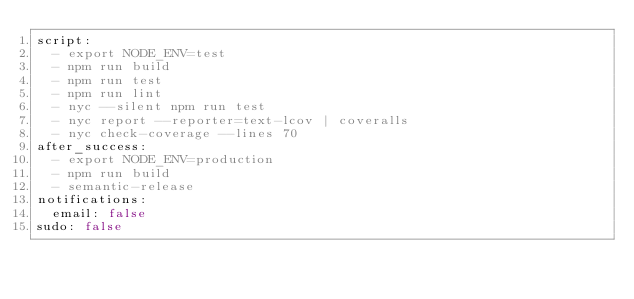<code> <loc_0><loc_0><loc_500><loc_500><_YAML_>script:
  - export NODE_ENV=test
  - npm run build
  - npm run test
  - npm run lint
  - nyc --silent npm run test
  - nyc report --reporter=text-lcov | coveralls
  - nyc check-coverage --lines 70
after_success:
  - export NODE_ENV=production
  - npm run build
  - semantic-release
notifications:
  email: false
sudo: false
</code> 